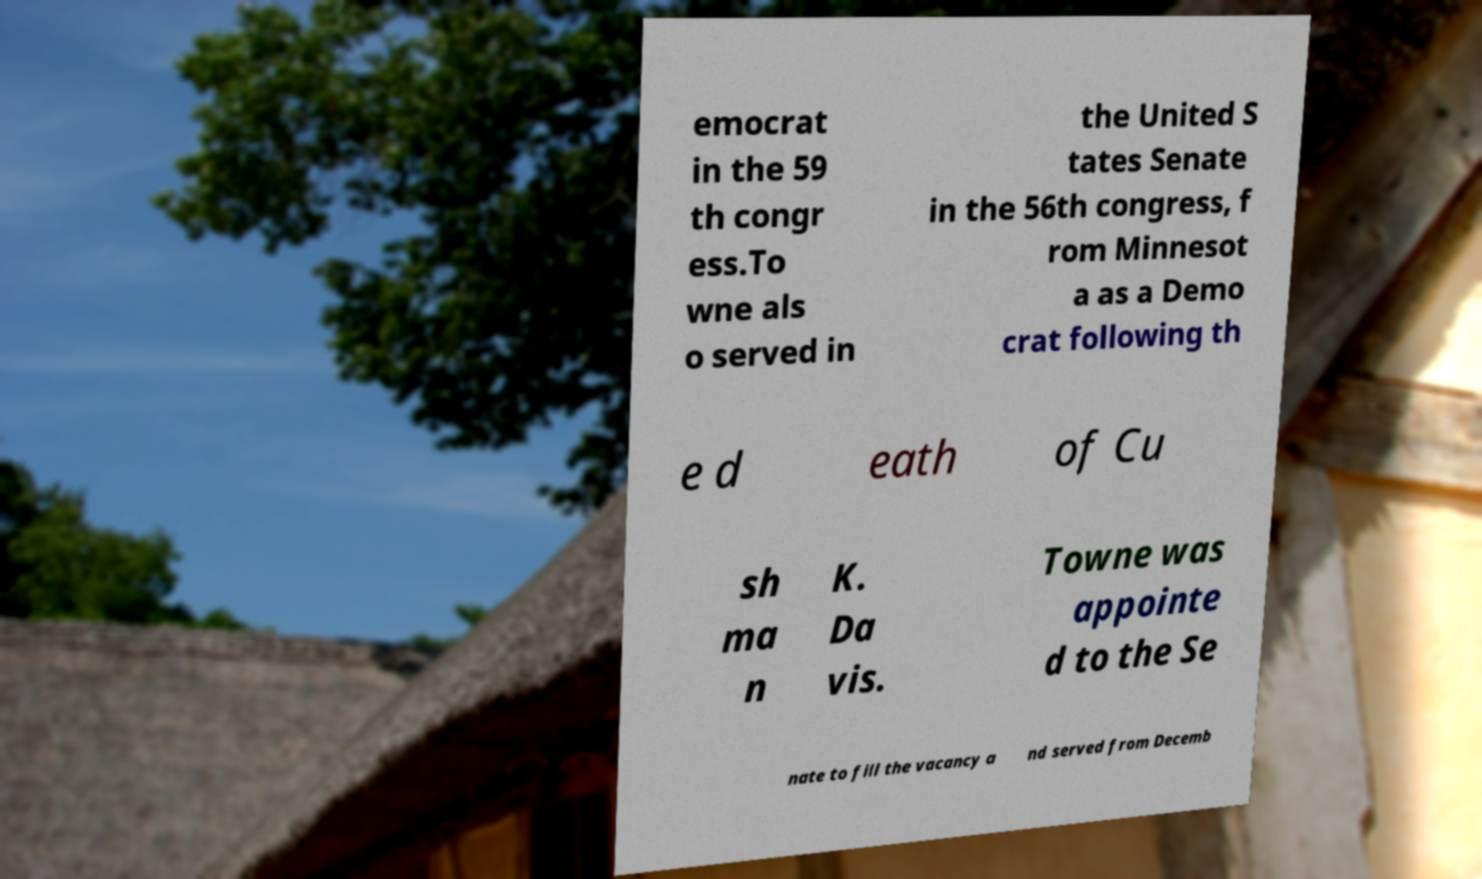For documentation purposes, I need the text within this image transcribed. Could you provide that? emocrat in the 59 th congr ess.To wne als o served in the United S tates Senate in the 56th congress, f rom Minnesot a as a Demo crat following th e d eath of Cu sh ma n K. Da vis. Towne was appointe d to the Se nate to fill the vacancy a nd served from Decemb 